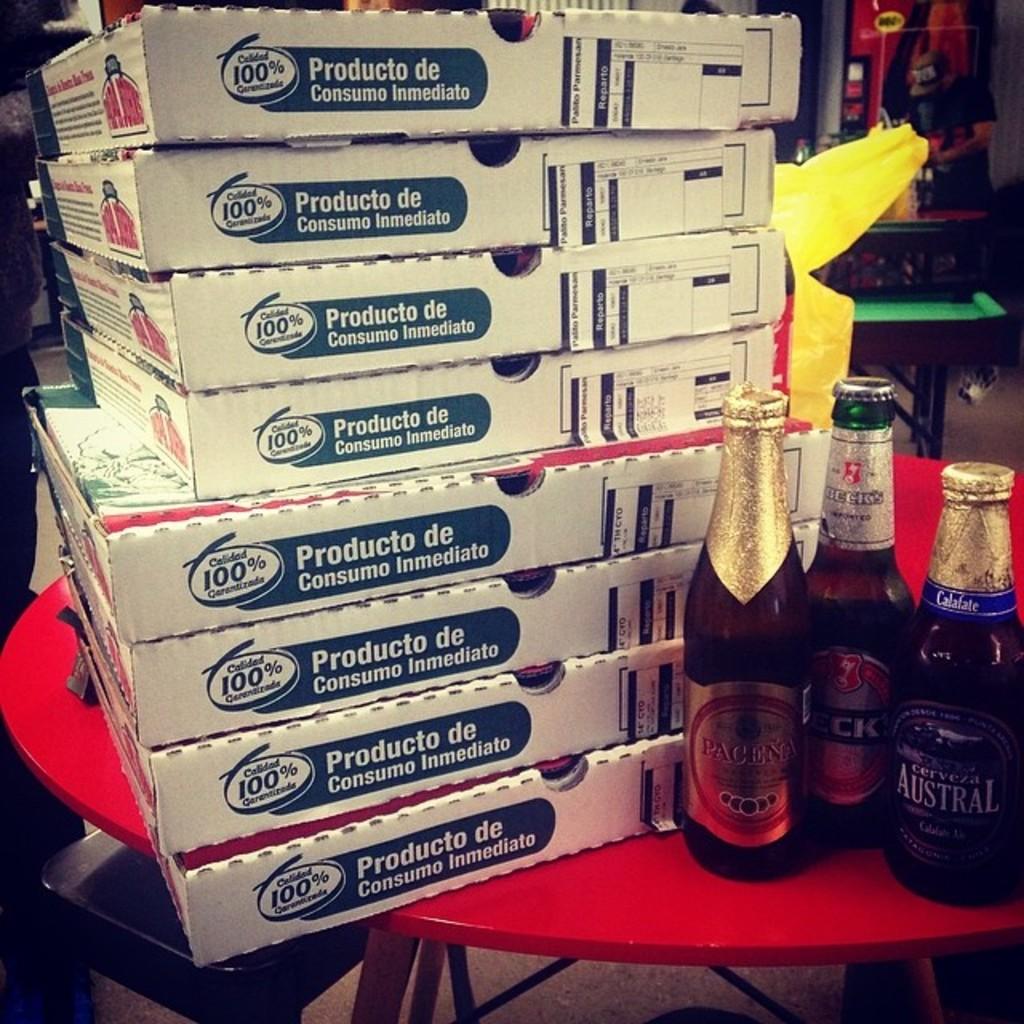What number can be seen on the box?
Offer a terse response. 100. What % satisfaction from the pizza company?
Give a very brief answer. 100. 